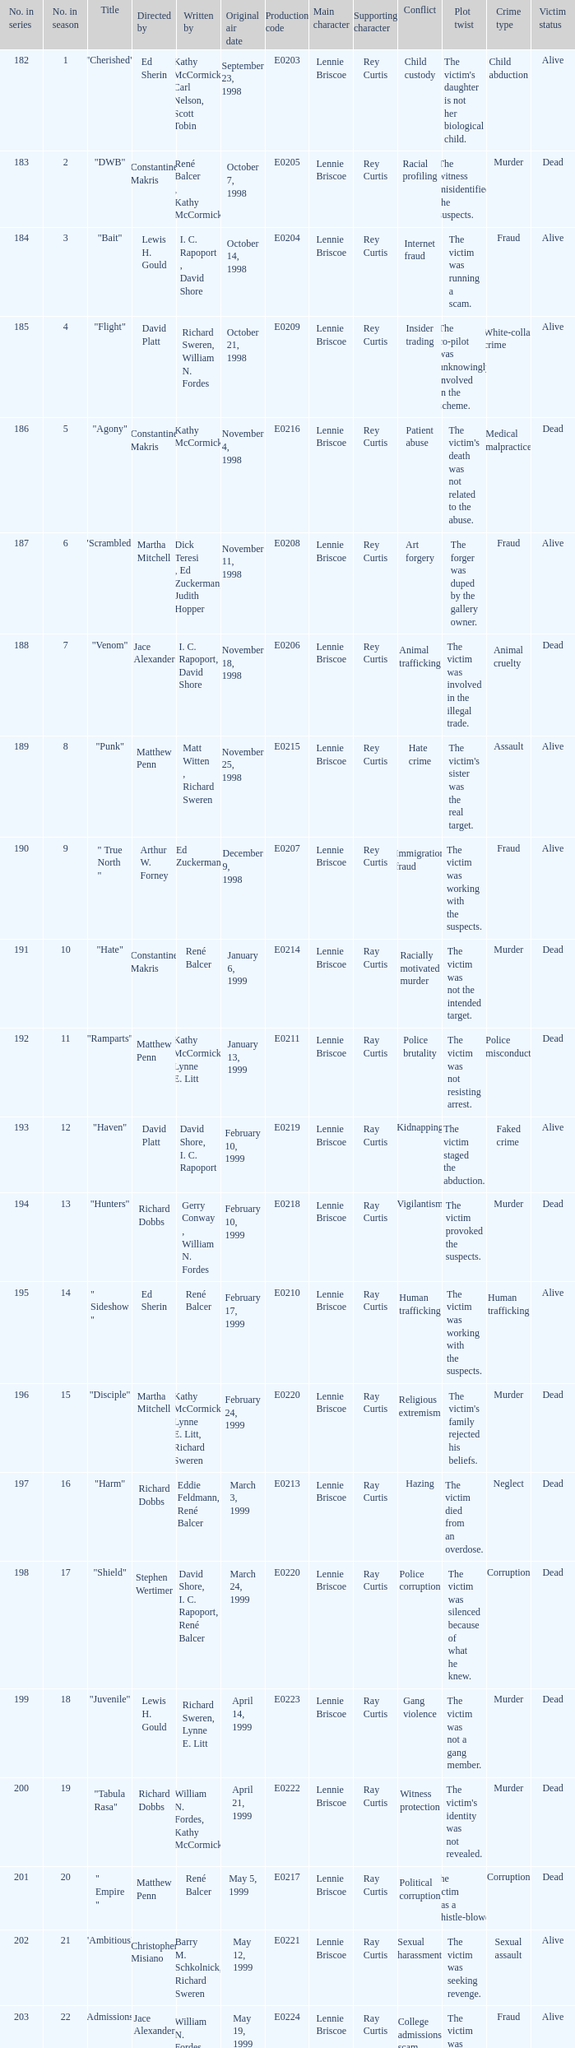The episode with the production code E0208 is directed by who? Martha Mitchell. 